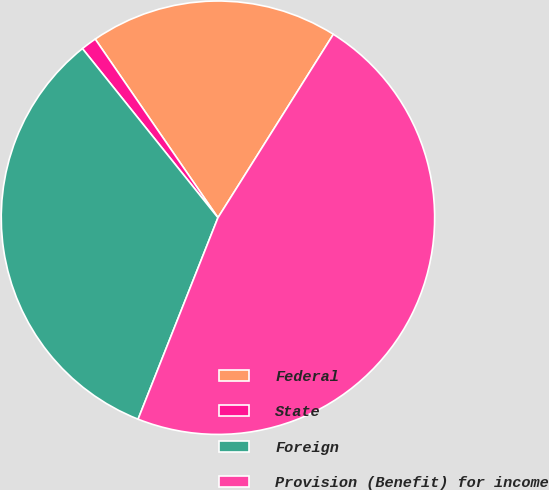Convert chart to OTSL. <chart><loc_0><loc_0><loc_500><loc_500><pie_chart><fcel>Federal<fcel>State<fcel>Foreign<fcel>Provision (Benefit) for income<nl><fcel>18.52%<fcel>1.17%<fcel>33.24%<fcel>47.07%<nl></chart> 